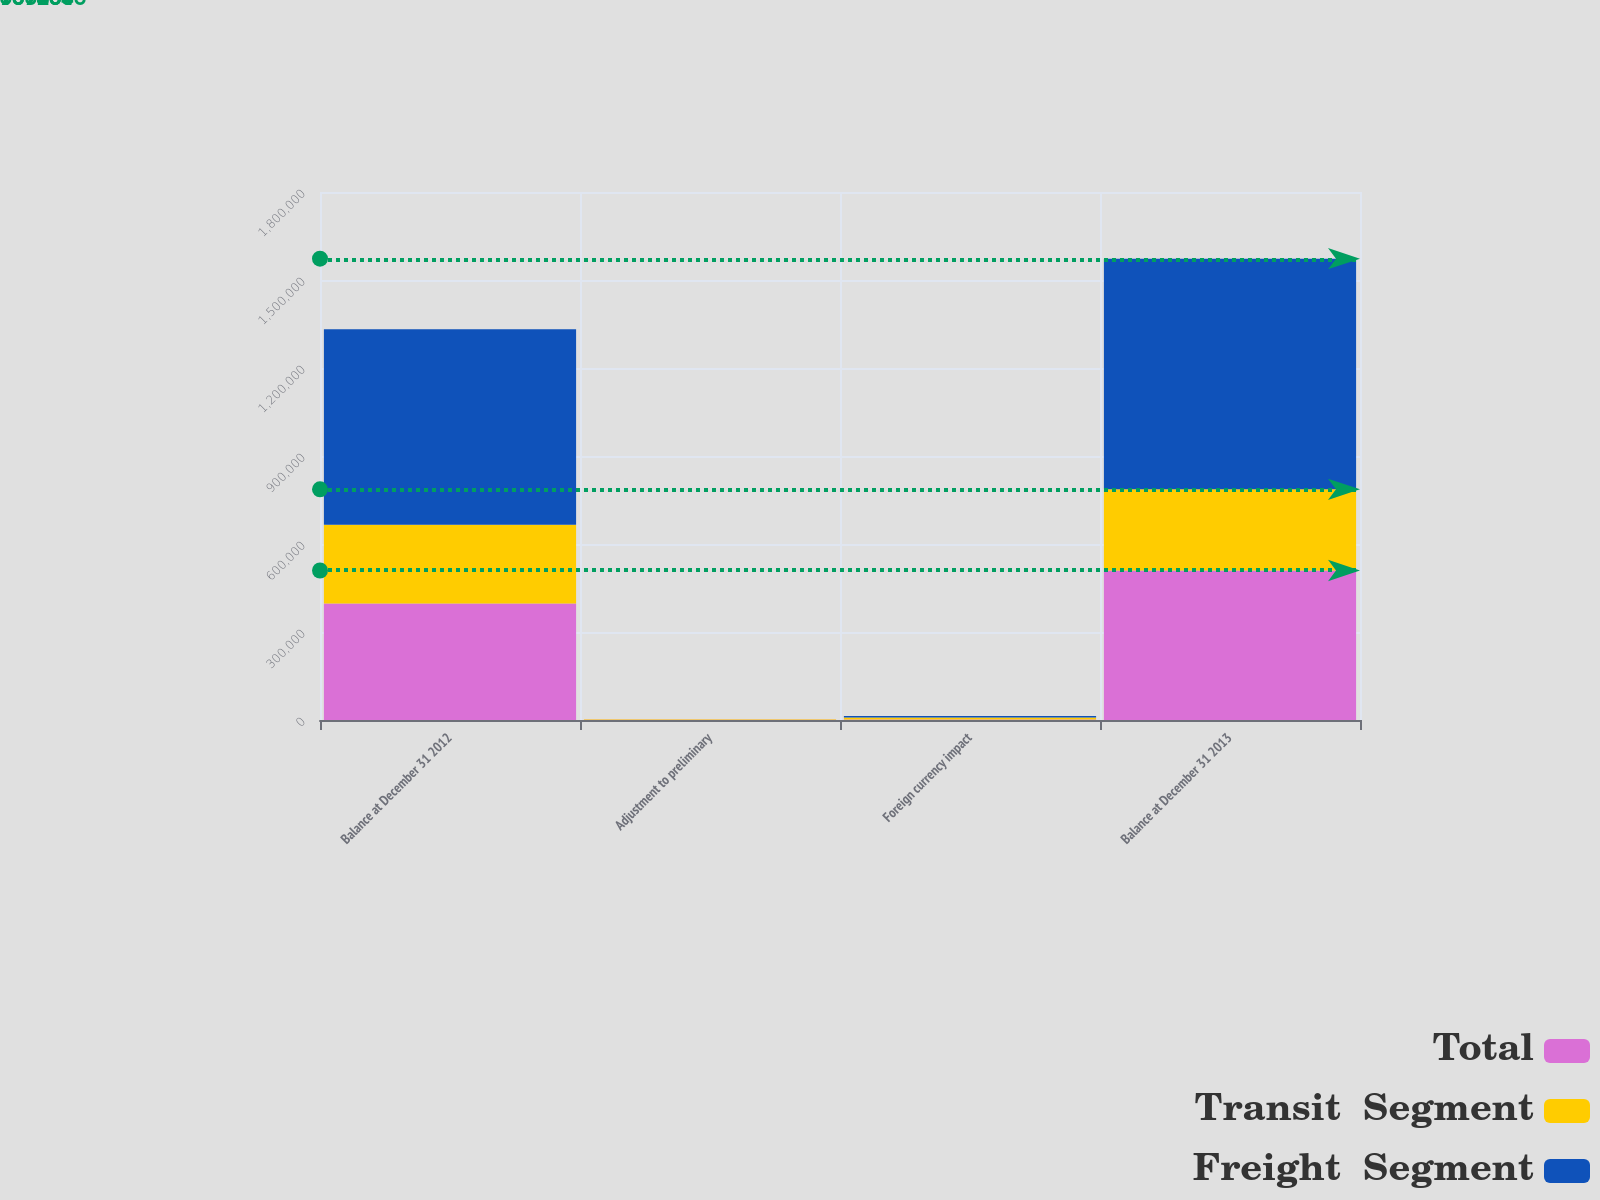Convert chart. <chart><loc_0><loc_0><loc_500><loc_500><stacked_bar_chart><ecel><fcel>Balance at December 31 2012<fcel>Adjustment to preliminary<fcel>Foreign currency impact<fcel>Balance at December 31 2013<nl><fcel>Total<fcel>397184<fcel>855<fcel>1727<fcel>509664<nl><fcel>Transit  Segment<fcel>268838<fcel>1303<fcel>6628<fcel>276769<nl><fcel>Freight  Segment<fcel>666022<fcel>448<fcel>4901<fcel>786433<nl></chart> 